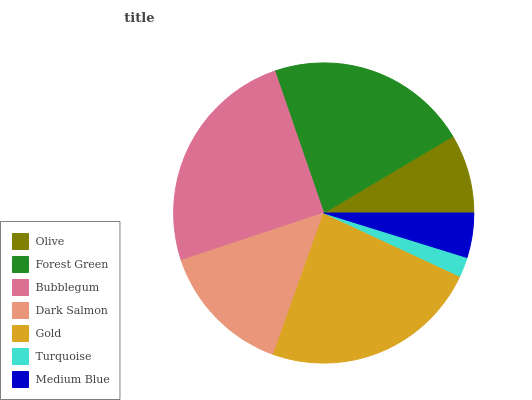Is Turquoise the minimum?
Answer yes or no. Yes. Is Bubblegum the maximum?
Answer yes or no. Yes. Is Forest Green the minimum?
Answer yes or no. No. Is Forest Green the maximum?
Answer yes or no. No. Is Forest Green greater than Olive?
Answer yes or no. Yes. Is Olive less than Forest Green?
Answer yes or no. Yes. Is Olive greater than Forest Green?
Answer yes or no. No. Is Forest Green less than Olive?
Answer yes or no. No. Is Dark Salmon the high median?
Answer yes or no. Yes. Is Dark Salmon the low median?
Answer yes or no. Yes. Is Turquoise the high median?
Answer yes or no. No. Is Gold the low median?
Answer yes or no. No. 